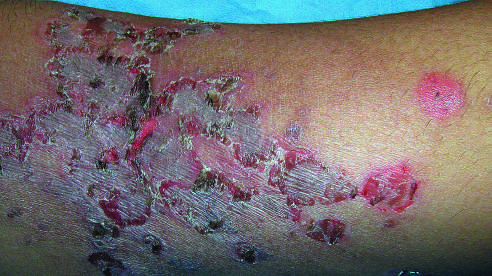what is involved by a superficial bacterial infection showing the characteristic erythematous scablike lesions crusted with dried serum?
Answer the question using a single word or phrase. A child's arm 